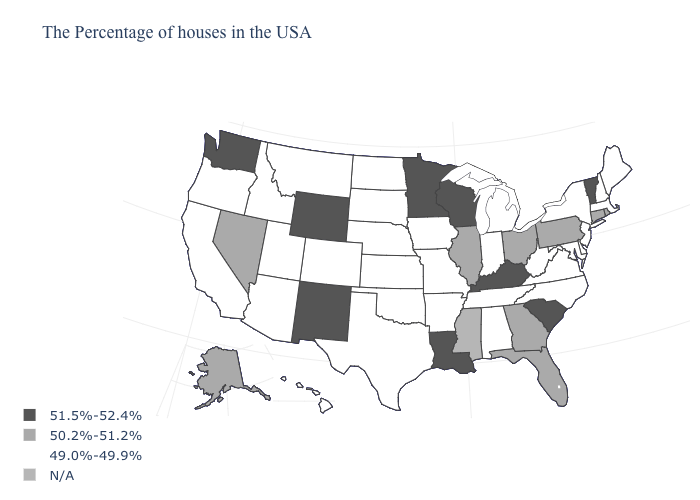Among the states that border Arkansas , which have the lowest value?
Short answer required. Tennessee, Missouri, Oklahoma, Texas. What is the value of Mississippi?
Give a very brief answer. N/A. Does the map have missing data?
Give a very brief answer. Yes. What is the lowest value in states that border Vermont?
Short answer required. 49.0%-49.9%. What is the value of California?
Be succinct. 49.0%-49.9%. Among the states that border New Jersey , which have the highest value?
Be succinct. Pennsylvania. Does Georgia have the highest value in the USA?
Keep it brief. No. What is the highest value in the USA?
Answer briefly. 51.5%-52.4%. Among the states that border Pennsylvania , does Ohio have the lowest value?
Quick response, please. No. What is the highest value in states that border Montana?
Short answer required. 51.5%-52.4%. What is the value of Nebraska?
Answer briefly. 49.0%-49.9%. Is the legend a continuous bar?
Concise answer only. No. What is the value of Indiana?
Keep it brief. 49.0%-49.9%. What is the lowest value in the USA?
Concise answer only. 49.0%-49.9%. What is the value of South Dakota?
Keep it brief. 49.0%-49.9%. 